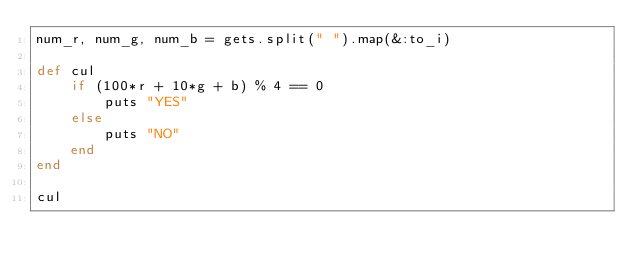<code> <loc_0><loc_0><loc_500><loc_500><_Ruby_>num_r, num_g, num_b = gets.split(" ").map(&:to_i)

def cul
    if (100*r + 10*g + b) % 4 == 0
        puts "YES"
    else
        puts "NO"
    end
end

cul</code> 